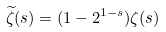Convert formula to latex. <formula><loc_0><loc_0><loc_500><loc_500>\widetilde { \zeta } ( s ) = ( 1 - 2 ^ { 1 - s } ) \zeta ( s )</formula> 